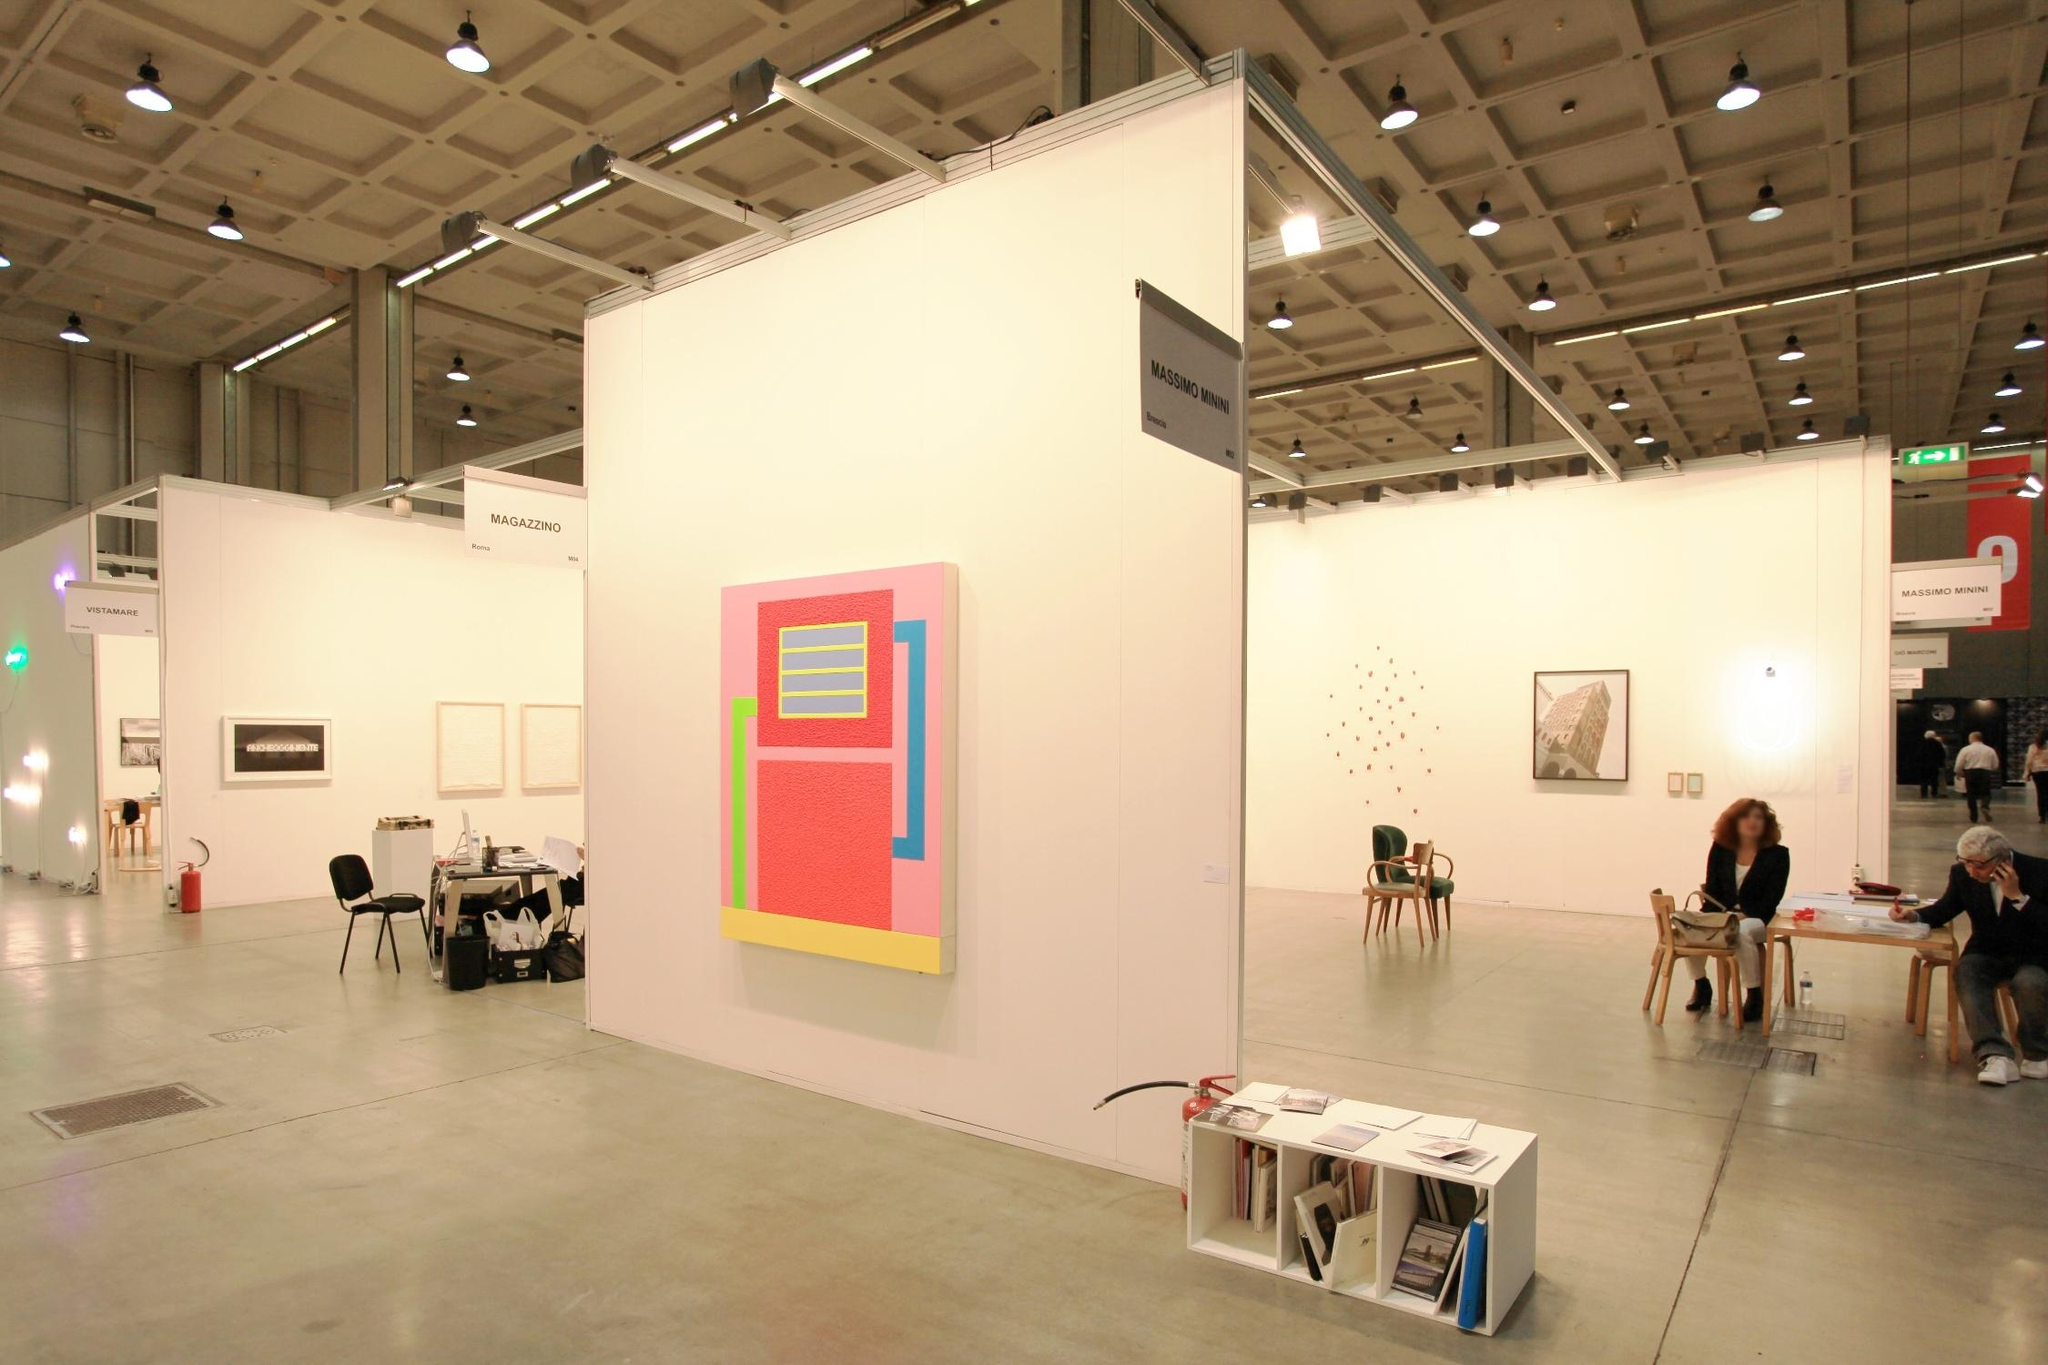What is the style of the central painting and what does it symbolize? The central painting embraces a style of geometric abstraction, using bold blocks of color to generate visual impact. The use of geometric forms and primary colors may suggest influences from modernist movements, such as De Stijl or Bauhaus, which emphasize simplicity and functionalism. The composition could symbolize themes of order and balance, highlighting how simplicity in form can lead to complexity in interpretation. 